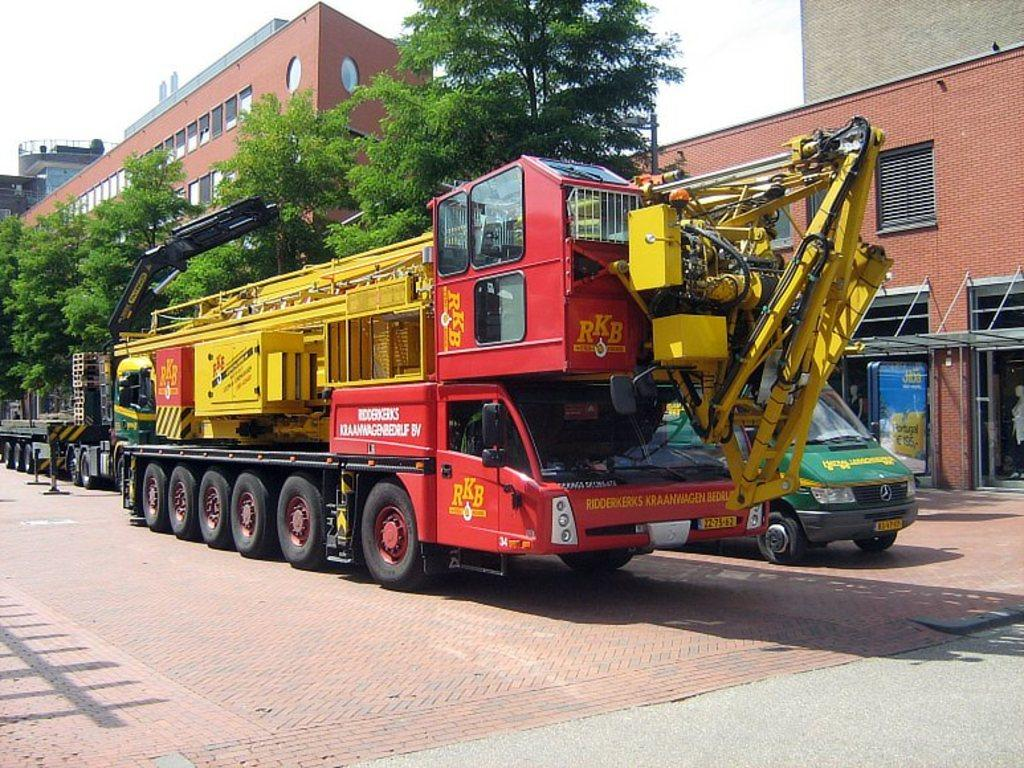What type of structures can be seen in the image? There are buildings in the image. What feature is visible on the buildings? There are windows visible in the image. What type of natural elements are present in the image? There are trees in the image. What man-made objects can be seen in the image? There are vehicles and a crane in the image. What additional object is present in the image? There is a board in the image. What is the color of the sky in the image? The sky appears to be white in color. How many cats are sitting on the table in the image? There is no table or cats present in the image. What type of fruit is hanging from the cherry tree in the image? There is no cherry tree present in the image. 